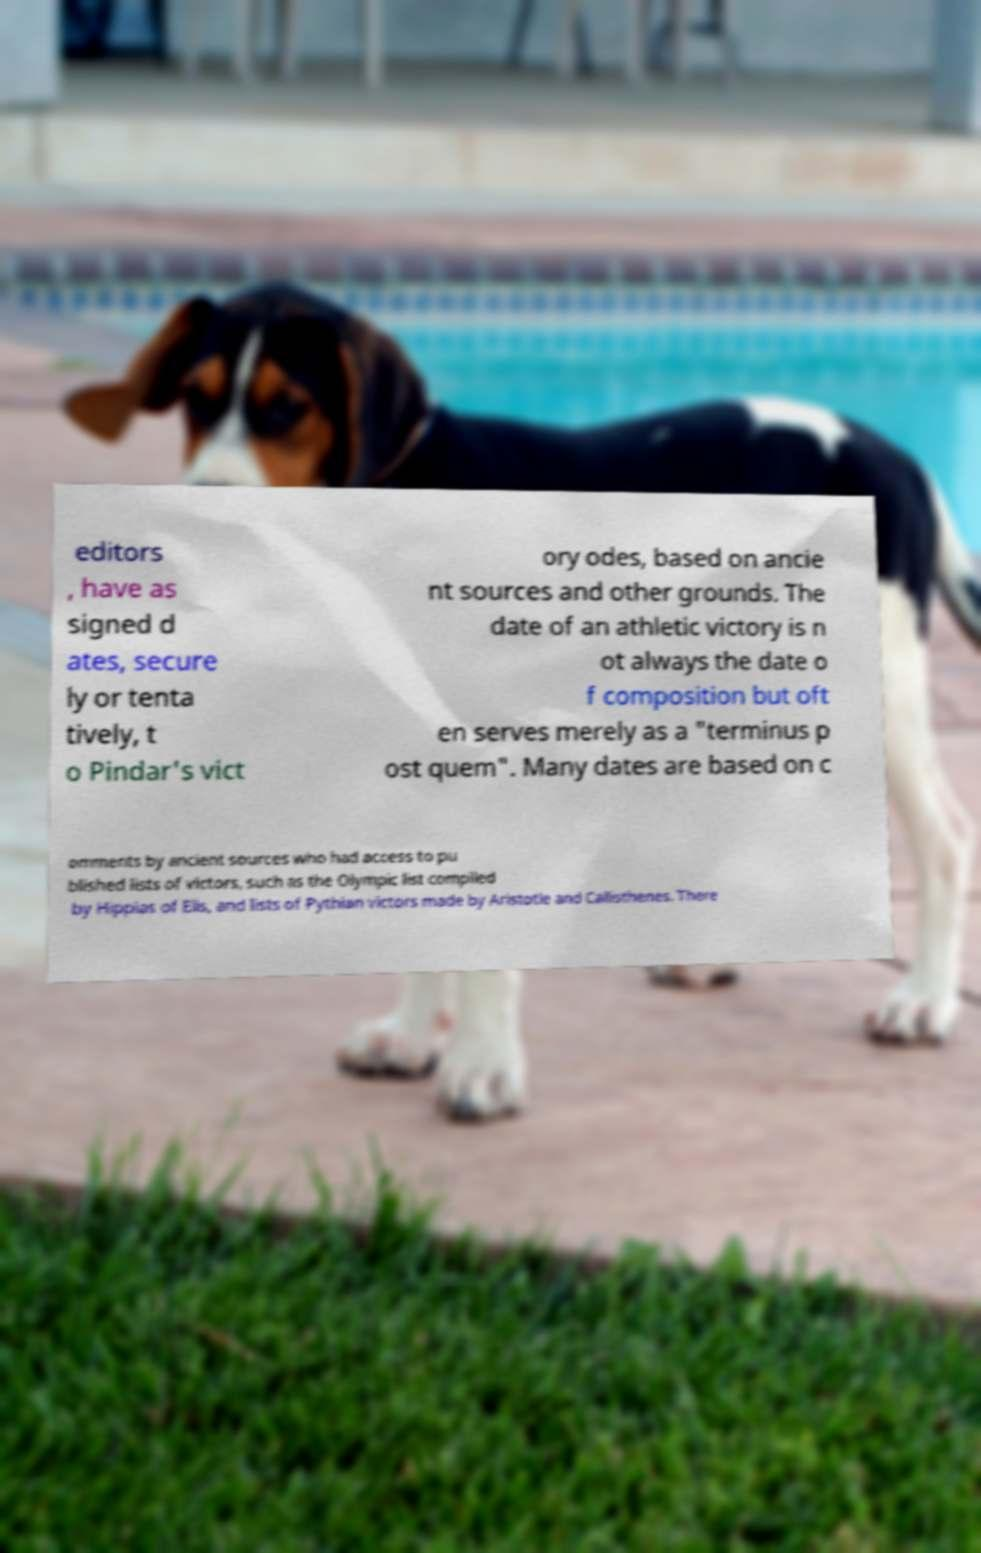Please identify and transcribe the text found in this image. editors , have as signed d ates, secure ly or tenta tively, t o Pindar's vict ory odes, based on ancie nt sources and other grounds. The date of an athletic victory is n ot always the date o f composition but oft en serves merely as a "terminus p ost quem". Many dates are based on c omments by ancient sources who had access to pu blished lists of victors, such as the Olympic list compiled by Hippias of Elis, and lists of Pythian victors made by Aristotle and Callisthenes. There 